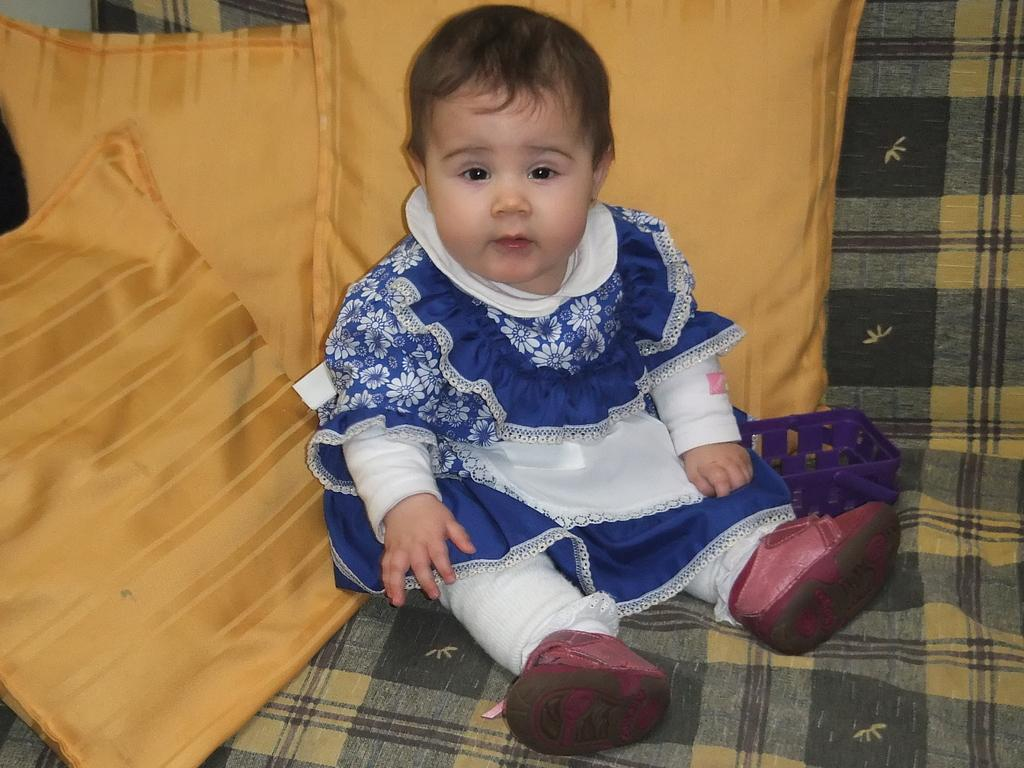What is the main subject of the image? The main subject of the image is a kid. What is the kid wearing in the image? The kid is wearing a white and blue dress in the image. Where is the kid sitting in the image? The kid is sitting on a sofa in the image. What can be seen on the sofa besides the kid? There are three yellow color pillows on the sofa in the image. What type of fang can be seen in the image? There is no fang present in the image. Does the existence of the kid in the image prove the existence of extraterrestrial life? The presence of the kid in the image does not prove the existence of extraterrestrial life, as the image only shows a kid sitting on a sofa. 